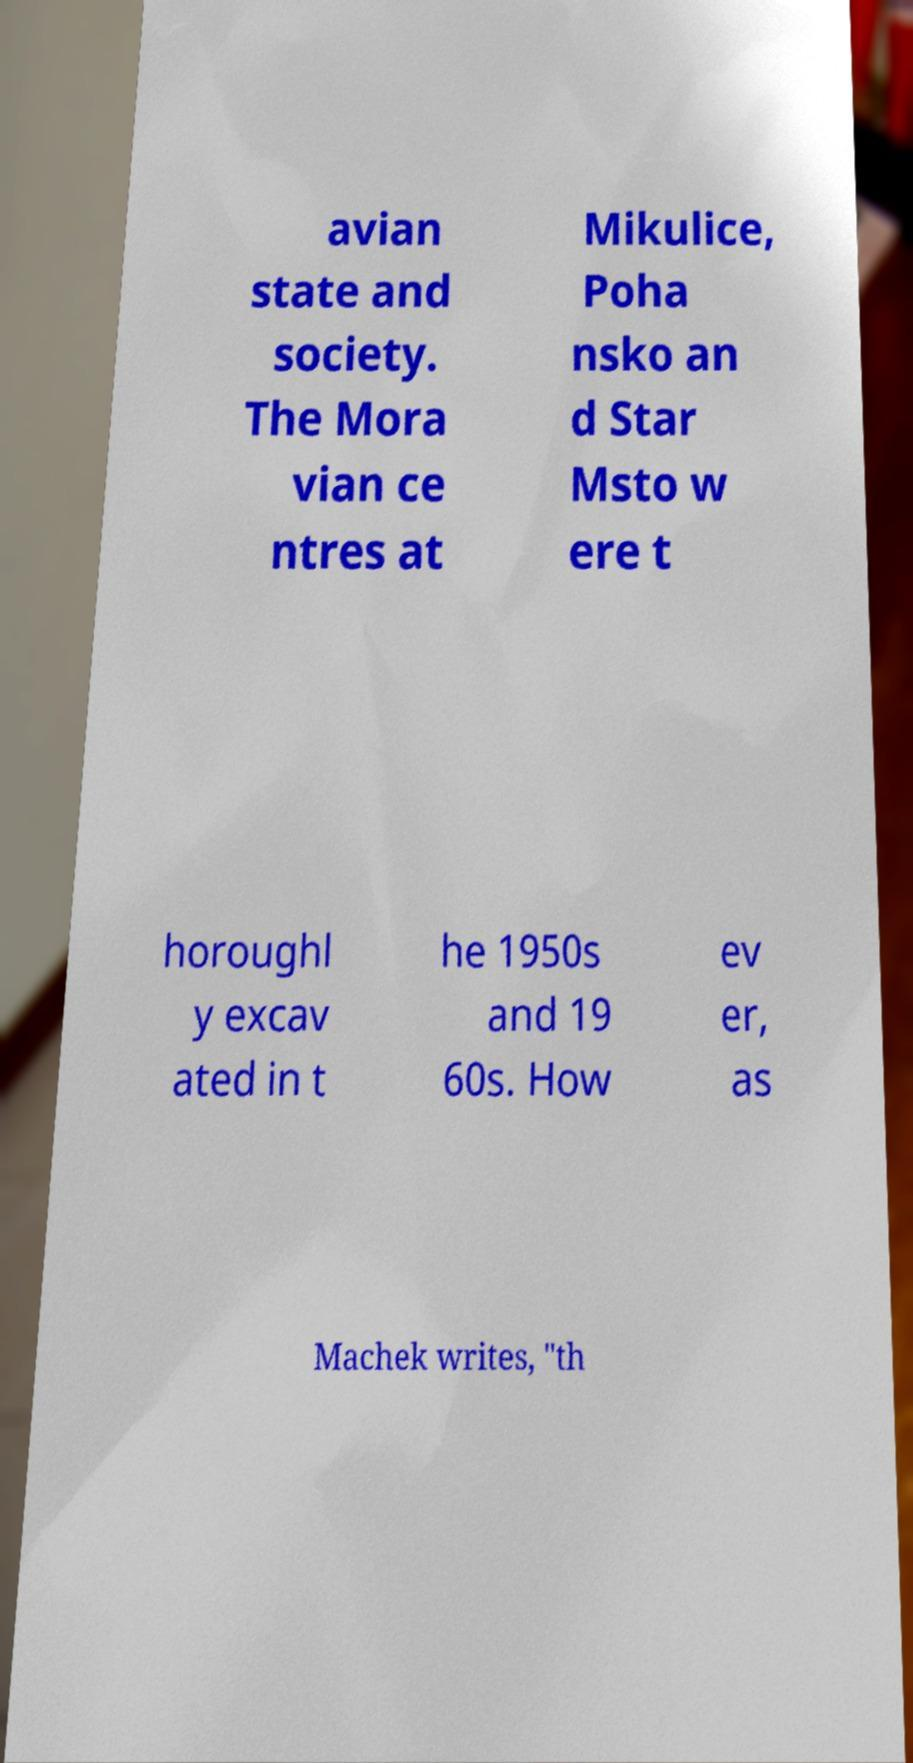Can you accurately transcribe the text from the provided image for me? avian state and society. The Mora vian ce ntres at Mikulice, Poha nsko an d Star Msto w ere t horoughl y excav ated in t he 1950s and 19 60s. How ev er, as Machek writes, "th 